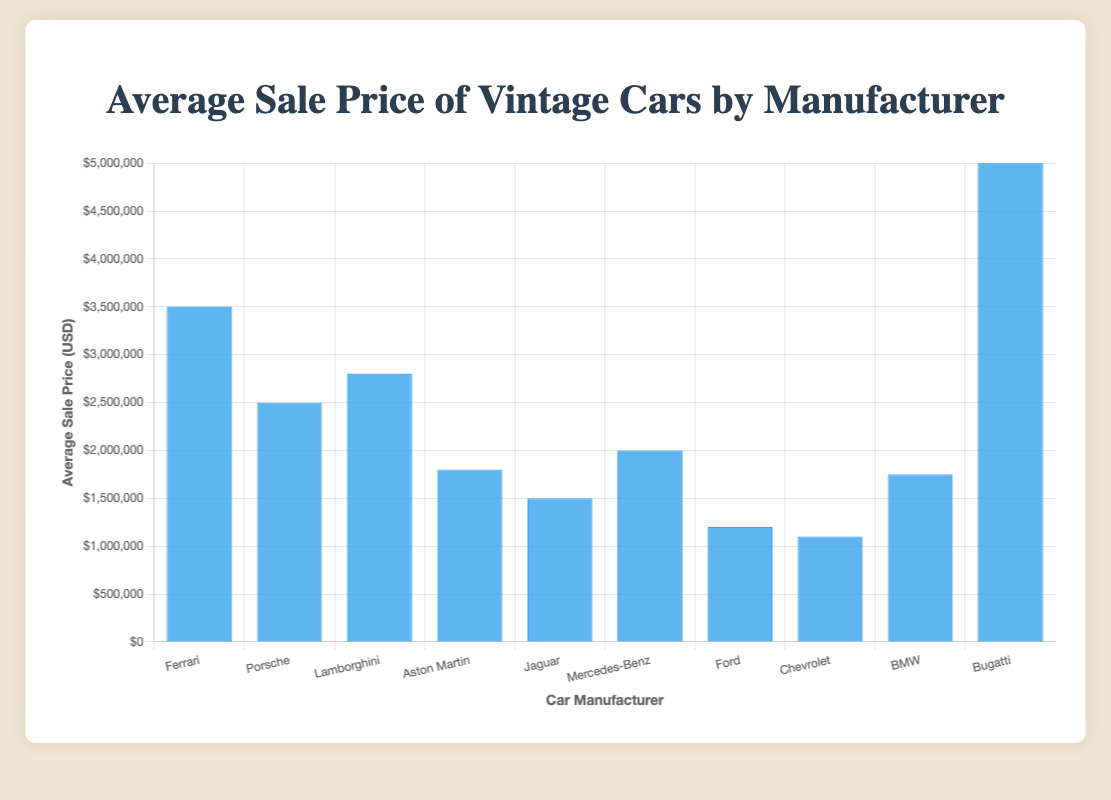Which car manufacturer has the highest average sale price? The bar for Bugatti is the tallest, indicating it has the highest average sale price.
Answer: Bugatti Which car manufacturer has the lowest average sale price? The bar for Chevrolet is the shortest, indicating it has the lowest average sale price.
Answer: Chevrolet How much higher is Bugatti's average sale price compared to Ferrari's? Bugatti's average sale price is $5,000,000, and Ferrari's average sale price is $3,500,000. The difference is $5,000,000 - $3,500,000 = $1,500,000.
Answer: $1,500,000 What is the average sale price range among all manufacturers? The highest average sale price is $5,000,000 (Bugatti) and the lowest is $1,100,000 (Chevrolet). The range is $5,000,000 - $1,100,000 = $3,900,000.
Answer: $3,900,000 Are there more manufacturers with an average sale price above $3,000,000 or below $1,500,000? Above $3,000,000 has 2 manufacturers (Bugatti and Ferrari). Below $1,500,000 has 2 manufacturers (Ford and Chevrolet).
Answer: Equal Which has a higher average sale price: Lamborghini or Mercedes-Benz? The average sale price for Lamborghini is $2,800,000, and for Mercedes-Benz it is $2,000,000. Lamborghini's average sale price is higher.
Answer: Lamborghini How many manufacturers have an average sale price between $1,000,000 and $2,000,000? The average sale prices between $1,000,000 and $2,000,000 are for Aston Martin ($1,800,000), Jaguar ($1,500,000), Ford ($1,200,000), Chevrolet ($1,100,000), and BMW ($1,750,000). There are 5 manufacturers.
Answer: 5 What is the combined average sale price of Porsche and Lamborghini? The average sale price for Porsche is $2,500,000, and for Lamborghini, it is $2,800,000. Their combined average sale price is $2,500,000 + $2,800,000 = $5,300,000.
Answer: $5,300,000 How much less is Jaguar's average sale price compared to the mean of Ferrari and Bugatti? The average sale price for Ferrari is $3,500,000 and Bugatti is $5,000,000. The mean is ($3,500,000 + $5,000,000)/2 = $4,250,000. Jaguar's average sale price is $1,500,000. The difference is $4,250,000 - $1,500,000 = $2,750,000.
Answer: $2,750,000 